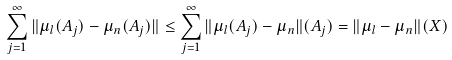Convert formula to latex. <formula><loc_0><loc_0><loc_500><loc_500>\sum _ { j = 1 } ^ { \infty } \| \mu _ { l } ( A _ { j } ) - \mu _ { n } ( A _ { j } ) \| \leq \sum _ { j = 1 } ^ { \infty } \| \mu _ { l } ( A _ { j } ) - \mu _ { n } \| ( A _ { j } ) = \| \mu _ { l } - \mu _ { n } \| ( X )</formula> 